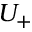<formula> <loc_0><loc_0><loc_500><loc_500>U _ { + }</formula> 